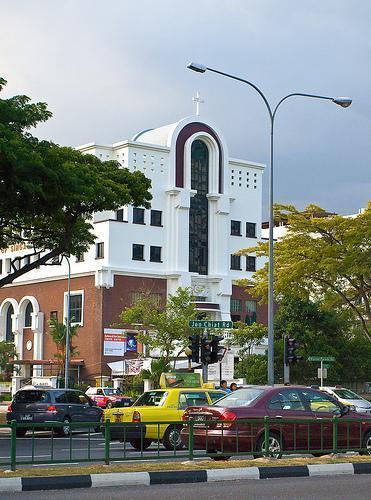How many cars?
Give a very brief answer. 5. How many red cars are there?
Give a very brief answer. 1. 